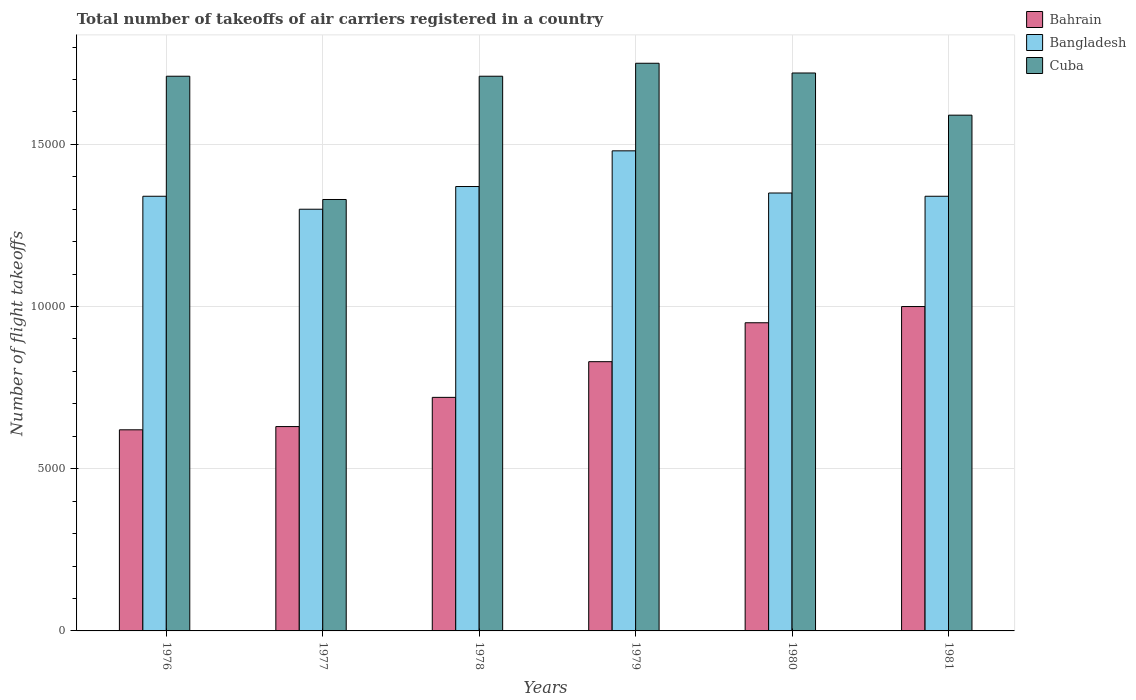How many different coloured bars are there?
Your answer should be compact. 3. Are the number of bars on each tick of the X-axis equal?
Provide a short and direct response. Yes. How many bars are there on the 5th tick from the right?
Provide a succinct answer. 3. In how many cases, is the number of bars for a given year not equal to the number of legend labels?
Keep it short and to the point. 0. What is the total number of flight takeoffs in Cuba in 1978?
Ensure brevity in your answer.  1.71e+04. Across all years, what is the minimum total number of flight takeoffs in Cuba?
Give a very brief answer. 1.33e+04. In which year was the total number of flight takeoffs in Cuba maximum?
Your answer should be very brief. 1979. In which year was the total number of flight takeoffs in Cuba minimum?
Provide a short and direct response. 1977. What is the total total number of flight takeoffs in Bahrain in the graph?
Make the answer very short. 4.75e+04. What is the difference between the total number of flight takeoffs in Bangladesh in 1979 and that in 1981?
Your answer should be compact. 1400. What is the difference between the total number of flight takeoffs in Cuba in 1976 and the total number of flight takeoffs in Bangladesh in 1978?
Make the answer very short. 3400. What is the average total number of flight takeoffs in Bangladesh per year?
Give a very brief answer. 1.36e+04. In the year 1979, what is the difference between the total number of flight takeoffs in Bahrain and total number of flight takeoffs in Cuba?
Ensure brevity in your answer.  -9200. In how many years, is the total number of flight takeoffs in Cuba greater than 8000?
Ensure brevity in your answer.  6. What is the ratio of the total number of flight takeoffs in Cuba in 1977 to that in 1979?
Ensure brevity in your answer.  0.76. Is the total number of flight takeoffs in Bangladesh in 1979 less than that in 1981?
Ensure brevity in your answer.  No. Is the difference between the total number of flight takeoffs in Bahrain in 1977 and 1979 greater than the difference between the total number of flight takeoffs in Cuba in 1977 and 1979?
Offer a very short reply. Yes. What is the difference between the highest and the lowest total number of flight takeoffs in Bahrain?
Make the answer very short. 3800. In how many years, is the total number of flight takeoffs in Bangladesh greater than the average total number of flight takeoffs in Bangladesh taken over all years?
Your answer should be very brief. 2. What does the 1st bar from the left in 1978 represents?
Your answer should be very brief. Bahrain. What does the 1st bar from the right in 1978 represents?
Your response must be concise. Cuba. What is the difference between two consecutive major ticks on the Y-axis?
Ensure brevity in your answer.  5000. Are the values on the major ticks of Y-axis written in scientific E-notation?
Offer a very short reply. No. Does the graph contain any zero values?
Provide a short and direct response. No. How are the legend labels stacked?
Your answer should be compact. Vertical. What is the title of the graph?
Your answer should be compact. Total number of takeoffs of air carriers registered in a country. Does "Curacao" appear as one of the legend labels in the graph?
Provide a short and direct response. No. What is the label or title of the Y-axis?
Keep it short and to the point. Number of flight takeoffs. What is the Number of flight takeoffs of Bahrain in 1976?
Offer a very short reply. 6200. What is the Number of flight takeoffs of Bangladesh in 1976?
Provide a succinct answer. 1.34e+04. What is the Number of flight takeoffs in Cuba in 1976?
Ensure brevity in your answer.  1.71e+04. What is the Number of flight takeoffs of Bahrain in 1977?
Make the answer very short. 6300. What is the Number of flight takeoffs of Bangladesh in 1977?
Offer a very short reply. 1.30e+04. What is the Number of flight takeoffs in Cuba in 1977?
Ensure brevity in your answer.  1.33e+04. What is the Number of flight takeoffs of Bahrain in 1978?
Make the answer very short. 7200. What is the Number of flight takeoffs of Bangladesh in 1978?
Ensure brevity in your answer.  1.37e+04. What is the Number of flight takeoffs in Cuba in 1978?
Your response must be concise. 1.71e+04. What is the Number of flight takeoffs in Bahrain in 1979?
Your answer should be very brief. 8300. What is the Number of flight takeoffs in Bangladesh in 1979?
Offer a very short reply. 1.48e+04. What is the Number of flight takeoffs of Cuba in 1979?
Offer a very short reply. 1.75e+04. What is the Number of flight takeoffs of Bahrain in 1980?
Provide a succinct answer. 9500. What is the Number of flight takeoffs in Bangladesh in 1980?
Give a very brief answer. 1.35e+04. What is the Number of flight takeoffs of Cuba in 1980?
Give a very brief answer. 1.72e+04. What is the Number of flight takeoffs in Bangladesh in 1981?
Your answer should be compact. 1.34e+04. What is the Number of flight takeoffs of Cuba in 1981?
Provide a succinct answer. 1.59e+04. Across all years, what is the maximum Number of flight takeoffs of Bahrain?
Ensure brevity in your answer.  10000. Across all years, what is the maximum Number of flight takeoffs in Bangladesh?
Keep it short and to the point. 1.48e+04. Across all years, what is the maximum Number of flight takeoffs of Cuba?
Offer a terse response. 1.75e+04. Across all years, what is the minimum Number of flight takeoffs of Bahrain?
Provide a succinct answer. 6200. Across all years, what is the minimum Number of flight takeoffs in Bangladesh?
Offer a terse response. 1.30e+04. Across all years, what is the minimum Number of flight takeoffs of Cuba?
Give a very brief answer. 1.33e+04. What is the total Number of flight takeoffs in Bahrain in the graph?
Ensure brevity in your answer.  4.75e+04. What is the total Number of flight takeoffs in Bangladesh in the graph?
Make the answer very short. 8.18e+04. What is the total Number of flight takeoffs of Cuba in the graph?
Your answer should be compact. 9.81e+04. What is the difference between the Number of flight takeoffs of Bahrain in 1976 and that in 1977?
Your answer should be very brief. -100. What is the difference between the Number of flight takeoffs of Bangladesh in 1976 and that in 1977?
Give a very brief answer. 400. What is the difference between the Number of flight takeoffs of Cuba in 1976 and that in 1977?
Give a very brief answer. 3800. What is the difference between the Number of flight takeoffs of Bahrain in 1976 and that in 1978?
Offer a very short reply. -1000. What is the difference between the Number of flight takeoffs of Bangladesh in 1976 and that in 1978?
Give a very brief answer. -300. What is the difference between the Number of flight takeoffs in Bahrain in 1976 and that in 1979?
Offer a terse response. -2100. What is the difference between the Number of flight takeoffs in Bangladesh in 1976 and that in 1979?
Offer a very short reply. -1400. What is the difference between the Number of flight takeoffs of Cuba in 1976 and that in 1979?
Your answer should be very brief. -400. What is the difference between the Number of flight takeoffs of Bahrain in 1976 and that in 1980?
Offer a terse response. -3300. What is the difference between the Number of flight takeoffs in Bangladesh in 1976 and that in 1980?
Provide a short and direct response. -100. What is the difference between the Number of flight takeoffs in Cuba in 1976 and that in 1980?
Your answer should be compact. -100. What is the difference between the Number of flight takeoffs of Bahrain in 1976 and that in 1981?
Your answer should be compact. -3800. What is the difference between the Number of flight takeoffs in Cuba in 1976 and that in 1981?
Offer a very short reply. 1200. What is the difference between the Number of flight takeoffs of Bahrain in 1977 and that in 1978?
Keep it short and to the point. -900. What is the difference between the Number of flight takeoffs in Bangladesh in 1977 and that in 1978?
Provide a short and direct response. -700. What is the difference between the Number of flight takeoffs of Cuba in 1977 and that in 1978?
Offer a very short reply. -3800. What is the difference between the Number of flight takeoffs in Bahrain in 1977 and that in 1979?
Offer a terse response. -2000. What is the difference between the Number of flight takeoffs in Bangladesh in 1977 and that in 1979?
Provide a short and direct response. -1800. What is the difference between the Number of flight takeoffs in Cuba in 1977 and that in 1979?
Your answer should be compact. -4200. What is the difference between the Number of flight takeoffs in Bahrain in 1977 and that in 1980?
Give a very brief answer. -3200. What is the difference between the Number of flight takeoffs in Bangladesh in 1977 and that in 1980?
Provide a succinct answer. -500. What is the difference between the Number of flight takeoffs of Cuba in 1977 and that in 1980?
Offer a very short reply. -3900. What is the difference between the Number of flight takeoffs in Bahrain in 1977 and that in 1981?
Offer a very short reply. -3700. What is the difference between the Number of flight takeoffs in Bangladesh in 1977 and that in 1981?
Your response must be concise. -400. What is the difference between the Number of flight takeoffs of Cuba in 1977 and that in 1981?
Ensure brevity in your answer.  -2600. What is the difference between the Number of flight takeoffs of Bahrain in 1978 and that in 1979?
Give a very brief answer. -1100. What is the difference between the Number of flight takeoffs of Bangladesh in 1978 and that in 1979?
Your response must be concise. -1100. What is the difference between the Number of flight takeoffs in Cuba in 1978 and that in 1979?
Offer a terse response. -400. What is the difference between the Number of flight takeoffs of Bahrain in 1978 and that in 1980?
Keep it short and to the point. -2300. What is the difference between the Number of flight takeoffs in Bangladesh in 1978 and that in 1980?
Make the answer very short. 200. What is the difference between the Number of flight takeoffs of Cuba in 1978 and that in 1980?
Ensure brevity in your answer.  -100. What is the difference between the Number of flight takeoffs in Bahrain in 1978 and that in 1981?
Offer a terse response. -2800. What is the difference between the Number of flight takeoffs of Bangladesh in 1978 and that in 1981?
Keep it short and to the point. 300. What is the difference between the Number of flight takeoffs of Cuba in 1978 and that in 1981?
Your answer should be compact. 1200. What is the difference between the Number of flight takeoffs of Bahrain in 1979 and that in 1980?
Keep it short and to the point. -1200. What is the difference between the Number of flight takeoffs of Bangladesh in 1979 and that in 1980?
Provide a succinct answer. 1300. What is the difference between the Number of flight takeoffs of Cuba in 1979 and that in 1980?
Keep it short and to the point. 300. What is the difference between the Number of flight takeoffs of Bahrain in 1979 and that in 1981?
Your response must be concise. -1700. What is the difference between the Number of flight takeoffs in Bangladesh in 1979 and that in 1981?
Offer a very short reply. 1400. What is the difference between the Number of flight takeoffs of Cuba in 1979 and that in 1981?
Your answer should be very brief. 1600. What is the difference between the Number of flight takeoffs of Bahrain in 1980 and that in 1981?
Keep it short and to the point. -500. What is the difference between the Number of flight takeoffs of Cuba in 1980 and that in 1981?
Your response must be concise. 1300. What is the difference between the Number of flight takeoffs in Bahrain in 1976 and the Number of flight takeoffs in Bangladesh in 1977?
Keep it short and to the point. -6800. What is the difference between the Number of flight takeoffs in Bahrain in 1976 and the Number of flight takeoffs in Cuba in 1977?
Ensure brevity in your answer.  -7100. What is the difference between the Number of flight takeoffs in Bahrain in 1976 and the Number of flight takeoffs in Bangladesh in 1978?
Keep it short and to the point. -7500. What is the difference between the Number of flight takeoffs in Bahrain in 1976 and the Number of flight takeoffs in Cuba in 1978?
Your response must be concise. -1.09e+04. What is the difference between the Number of flight takeoffs of Bangladesh in 1976 and the Number of flight takeoffs of Cuba in 1978?
Offer a very short reply. -3700. What is the difference between the Number of flight takeoffs of Bahrain in 1976 and the Number of flight takeoffs of Bangladesh in 1979?
Provide a succinct answer. -8600. What is the difference between the Number of flight takeoffs in Bahrain in 1976 and the Number of flight takeoffs in Cuba in 1979?
Ensure brevity in your answer.  -1.13e+04. What is the difference between the Number of flight takeoffs in Bangladesh in 1976 and the Number of flight takeoffs in Cuba in 1979?
Ensure brevity in your answer.  -4100. What is the difference between the Number of flight takeoffs of Bahrain in 1976 and the Number of flight takeoffs of Bangladesh in 1980?
Provide a short and direct response. -7300. What is the difference between the Number of flight takeoffs in Bahrain in 1976 and the Number of flight takeoffs in Cuba in 1980?
Offer a terse response. -1.10e+04. What is the difference between the Number of flight takeoffs in Bangladesh in 1976 and the Number of flight takeoffs in Cuba in 1980?
Your response must be concise. -3800. What is the difference between the Number of flight takeoffs in Bahrain in 1976 and the Number of flight takeoffs in Bangladesh in 1981?
Ensure brevity in your answer.  -7200. What is the difference between the Number of flight takeoffs in Bahrain in 1976 and the Number of flight takeoffs in Cuba in 1981?
Give a very brief answer. -9700. What is the difference between the Number of flight takeoffs of Bangladesh in 1976 and the Number of flight takeoffs of Cuba in 1981?
Provide a short and direct response. -2500. What is the difference between the Number of flight takeoffs in Bahrain in 1977 and the Number of flight takeoffs in Bangladesh in 1978?
Give a very brief answer. -7400. What is the difference between the Number of flight takeoffs in Bahrain in 1977 and the Number of flight takeoffs in Cuba in 1978?
Your answer should be very brief. -1.08e+04. What is the difference between the Number of flight takeoffs in Bangladesh in 1977 and the Number of flight takeoffs in Cuba in 1978?
Your answer should be compact. -4100. What is the difference between the Number of flight takeoffs of Bahrain in 1977 and the Number of flight takeoffs of Bangladesh in 1979?
Your answer should be very brief. -8500. What is the difference between the Number of flight takeoffs in Bahrain in 1977 and the Number of flight takeoffs in Cuba in 1979?
Ensure brevity in your answer.  -1.12e+04. What is the difference between the Number of flight takeoffs of Bangladesh in 1977 and the Number of flight takeoffs of Cuba in 1979?
Offer a terse response. -4500. What is the difference between the Number of flight takeoffs in Bahrain in 1977 and the Number of flight takeoffs in Bangladesh in 1980?
Your answer should be compact. -7200. What is the difference between the Number of flight takeoffs in Bahrain in 1977 and the Number of flight takeoffs in Cuba in 1980?
Provide a short and direct response. -1.09e+04. What is the difference between the Number of flight takeoffs of Bangladesh in 1977 and the Number of flight takeoffs of Cuba in 1980?
Make the answer very short. -4200. What is the difference between the Number of flight takeoffs of Bahrain in 1977 and the Number of flight takeoffs of Bangladesh in 1981?
Keep it short and to the point. -7100. What is the difference between the Number of flight takeoffs of Bahrain in 1977 and the Number of flight takeoffs of Cuba in 1981?
Your response must be concise. -9600. What is the difference between the Number of flight takeoffs of Bangladesh in 1977 and the Number of flight takeoffs of Cuba in 1981?
Provide a short and direct response. -2900. What is the difference between the Number of flight takeoffs in Bahrain in 1978 and the Number of flight takeoffs in Bangladesh in 1979?
Your answer should be very brief. -7600. What is the difference between the Number of flight takeoffs in Bahrain in 1978 and the Number of flight takeoffs in Cuba in 1979?
Give a very brief answer. -1.03e+04. What is the difference between the Number of flight takeoffs of Bangladesh in 1978 and the Number of flight takeoffs of Cuba in 1979?
Your answer should be compact. -3800. What is the difference between the Number of flight takeoffs in Bahrain in 1978 and the Number of flight takeoffs in Bangladesh in 1980?
Provide a succinct answer. -6300. What is the difference between the Number of flight takeoffs in Bangladesh in 1978 and the Number of flight takeoffs in Cuba in 1980?
Your answer should be very brief. -3500. What is the difference between the Number of flight takeoffs in Bahrain in 1978 and the Number of flight takeoffs in Bangladesh in 1981?
Keep it short and to the point. -6200. What is the difference between the Number of flight takeoffs of Bahrain in 1978 and the Number of flight takeoffs of Cuba in 1981?
Your response must be concise. -8700. What is the difference between the Number of flight takeoffs in Bangladesh in 1978 and the Number of flight takeoffs in Cuba in 1981?
Your response must be concise. -2200. What is the difference between the Number of flight takeoffs of Bahrain in 1979 and the Number of flight takeoffs of Bangladesh in 1980?
Your answer should be compact. -5200. What is the difference between the Number of flight takeoffs in Bahrain in 1979 and the Number of flight takeoffs in Cuba in 1980?
Offer a terse response. -8900. What is the difference between the Number of flight takeoffs of Bangladesh in 1979 and the Number of flight takeoffs of Cuba in 1980?
Offer a very short reply. -2400. What is the difference between the Number of flight takeoffs in Bahrain in 1979 and the Number of flight takeoffs in Bangladesh in 1981?
Ensure brevity in your answer.  -5100. What is the difference between the Number of flight takeoffs in Bahrain in 1979 and the Number of flight takeoffs in Cuba in 1981?
Provide a short and direct response. -7600. What is the difference between the Number of flight takeoffs of Bangladesh in 1979 and the Number of flight takeoffs of Cuba in 1981?
Your answer should be compact. -1100. What is the difference between the Number of flight takeoffs in Bahrain in 1980 and the Number of flight takeoffs in Bangladesh in 1981?
Offer a very short reply. -3900. What is the difference between the Number of flight takeoffs of Bahrain in 1980 and the Number of flight takeoffs of Cuba in 1981?
Offer a terse response. -6400. What is the difference between the Number of flight takeoffs in Bangladesh in 1980 and the Number of flight takeoffs in Cuba in 1981?
Make the answer very short. -2400. What is the average Number of flight takeoffs of Bahrain per year?
Your response must be concise. 7916.67. What is the average Number of flight takeoffs in Bangladesh per year?
Keep it short and to the point. 1.36e+04. What is the average Number of flight takeoffs in Cuba per year?
Give a very brief answer. 1.64e+04. In the year 1976, what is the difference between the Number of flight takeoffs of Bahrain and Number of flight takeoffs of Bangladesh?
Offer a terse response. -7200. In the year 1976, what is the difference between the Number of flight takeoffs in Bahrain and Number of flight takeoffs in Cuba?
Offer a terse response. -1.09e+04. In the year 1976, what is the difference between the Number of flight takeoffs in Bangladesh and Number of flight takeoffs in Cuba?
Make the answer very short. -3700. In the year 1977, what is the difference between the Number of flight takeoffs in Bahrain and Number of flight takeoffs in Bangladesh?
Give a very brief answer. -6700. In the year 1977, what is the difference between the Number of flight takeoffs of Bahrain and Number of flight takeoffs of Cuba?
Your answer should be very brief. -7000. In the year 1977, what is the difference between the Number of flight takeoffs in Bangladesh and Number of flight takeoffs in Cuba?
Offer a very short reply. -300. In the year 1978, what is the difference between the Number of flight takeoffs of Bahrain and Number of flight takeoffs of Bangladesh?
Provide a succinct answer. -6500. In the year 1978, what is the difference between the Number of flight takeoffs of Bahrain and Number of flight takeoffs of Cuba?
Provide a succinct answer. -9900. In the year 1978, what is the difference between the Number of flight takeoffs in Bangladesh and Number of flight takeoffs in Cuba?
Your answer should be compact. -3400. In the year 1979, what is the difference between the Number of flight takeoffs in Bahrain and Number of flight takeoffs in Bangladesh?
Make the answer very short. -6500. In the year 1979, what is the difference between the Number of flight takeoffs in Bahrain and Number of flight takeoffs in Cuba?
Ensure brevity in your answer.  -9200. In the year 1979, what is the difference between the Number of flight takeoffs in Bangladesh and Number of flight takeoffs in Cuba?
Offer a very short reply. -2700. In the year 1980, what is the difference between the Number of flight takeoffs in Bahrain and Number of flight takeoffs in Bangladesh?
Make the answer very short. -4000. In the year 1980, what is the difference between the Number of flight takeoffs of Bahrain and Number of flight takeoffs of Cuba?
Your response must be concise. -7700. In the year 1980, what is the difference between the Number of flight takeoffs of Bangladesh and Number of flight takeoffs of Cuba?
Offer a terse response. -3700. In the year 1981, what is the difference between the Number of flight takeoffs in Bahrain and Number of flight takeoffs in Bangladesh?
Your answer should be very brief. -3400. In the year 1981, what is the difference between the Number of flight takeoffs in Bahrain and Number of flight takeoffs in Cuba?
Ensure brevity in your answer.  -5900. In the year 1981, what is the difference between the Number of flight takeoffs in Bangladesh and Number of flight takeoffs in Cuba?
Your answer should be compact. -2500. What is the ratio of the Number of flight takeoffs in Bahrain in 1976 to that in 1977?
Provide a short and direct response. 0.98. What is the ratio of the Number of flight takeoffs in Bangladesh in 1976 to that in 1977?
Provide a short and direct response. 1.03. What is the ratio of the Number of flight takeoffs of Cuba in 1976 to that in 1977?
Make the answer very short. 1.29. What is the ratio of the Number of flight takeoffs of Bahrain in 1976 to that in 1978?
Offer a very short reply. 0.86. What is the ratio of the Number of flight takeoffs in Bangladesh in 1976 to that in 1978?
Provide a short and direct response. 0.98. What is the ratio of the Number of flight takeoffs in Cuba in 1976 to that in 1978?
Keep it short and to the point. 1. What is the ratio of the Number of flight takeoffs of Bahrain in 1976 to that in 1979?
Provide a succinct answer. 0.75. What is the ratio of the Number of flight takeoffs of Bangladesh in 1976 to that in 1979?
Offer a very short reply. 0.91. What is the ratio of the Number of flight takeoffs in Cuba in 1976 to that in 1979?
Your answer should be very brief. 0.98. What is the ratio of the Number of flight takeoffs in Bahrain in 1976 to that in 1980?
Ensure brevity in your answer.  0.65. What is the ratio of the Number of flight takeoffs in Bangladesh in 1976 to that in 1980?
Your answer should be compact. 0.99. What is the ratio of the Number of flight takeoffs of Cuba in 1976 to that in 1980?
Offer a terse response. 0.99. What is the ratio of the Number of flight takeoffs of Bahrain in 1976 to that in 1981?
Provide a short and direct response. 0.62. What is the ratio of the Number of flight takeoffs of Cuba in 1976 to that in 1981?
Your response must be concise. 1.08. What is the ratio of the Number of flight takeoffs of Bahrain in 1977 to that in 1978?
Offer a terse response. 0.88. What is the ratio of the Number of flight takeoffs in Bangladesh in 1977 to that in 1978?
Your answer should be very brief. 0.95. What is the ratio of the Number of flight takeoffs of Cuba in 1977 to that in 1978?
Ensure brevity in your answer.  0.78. What is the ratio of the Number of flight takeoffs in Bahrain in 1977 to that in 1979?
Give a very brief answer. 0.76. What is the ratio of the Number of flight takeoffs of Bangladesh in 1977 to that in 1979?
Give a very brief answer. 0.88. What is the ratio of the Number of flight takeoffs of Cuba in 1977 to that in 1979?
Provide a succinct answer. 0.76. What is the ratio of the Number of flight takeoffs of Bahrain in 1977 to that in 1980?
Your answer should be compact. 0.66. What is the ratio of the Number of flight takeoffs of Cuba in 1977 to that in 1980?
Offer a very short reply. 0.77. What is the ratio of the Number of flight takeoffs of Bahrain in 1977 to that in 1981?
Give a very brief answer. 0.63. What is the ratio of the Number of flight takeoffs in Bangladesh in 1977 to that in 1981?
Provide a short and direct response. 0.97. What is the ratio of the Number of flight takeoffs of Cuba in 1977 to that in 1981?
Provide a short and direct response. 0.84. What is the ratio of the Number of flight takeoffs in Bahrain in 1978 to that in 1979?
Keep it short and to the point. 0.87. What is the ratio of the Number of flight takeoffs in Bangladesh in 1978 to that in 1979?
Ensure brevity in your answer.  0.93. What is the ratio of the Number of flight takeoffs in Cuba in 1978 to that in 1979?
Provide a short and direct response. 0.98. What is the ratio of the Number of flight takeoffs of Bahrain in 1978 to that in 1980?
Provide a succinct answer. 0.76. What is the ratio of the Number of flight takeoffs of Bangladesh in 1978 to that in 1980?
Provide a short and direct response. 1.01. What is the ratio of the Number of flight takeoffs in Bahrain in 1978 to that in 1981?
Give a very brief answer. 0.72. What is the ratio of the Number of flight takeoffs of Bangladesh in 1978 to that in 1981?
Your answer should be compact. 1.02. What is the ratio of the Number of flight takeoffs in Cuba in 1978 to that in 1981?
Keep it short and to the point. 1.08. What is the ratio of the Number of flight takeoffs of Bahrain in 1979 to that in 1980?
Make the answer very short. 0.87. What is the ratio of the Number of flight takeoffs of Bangladesh in 1979 to that in 1980?
Offer a very short reply. 1.1. What is the ratio of the Number of flight takeoffs in Cuba in 1979 to that in 1980?
Your answer should be compact. 1.02. What is the ratio of the Number of flight takeoffs of Bahrain in 1979 to that in 1981?
Offer a very short reply. 0.83. What is the ratio of the Number of flight takeoffs in Bangladesh in 1979 to that in 1981?
Make the answer very short. 1.1. What is the ratio of the Number of flight takeoffs in Cuba in 1979 to that in 1981?
Keep it short and to the point. 1.1. What is the ratio of the Number of flight takeoffs of Bahrain in 1980 to that in 1981?
Give a very brief answer. 0.95. What is the ratio of the Number of flight takeoffs in Bangladesh in 1980 to that in 1981?
Provide a short and direct response. 1.01. What is the ratio of the Number of flight takeoffs in Cuba in 1980 to that in 1981?
Your answer should be very brief. 1.08. What is the difference between the highest and the second highest Number of flight takeoffs in Bangladesh?
Your answer should be compact. 1100. What is the difference between the highest and the second highest Number of flight takeoffs in Cuba?
Offer a very short reply. 300. What is the difference between the highest and the lowest Number of flight takeoffs of Bahrain?
Offer a very short reply. 3800. What is the difference between the highest and the lowest Number of flight takeoffs of Bangladesh?
Offer a terse response. 1800. What is the difference between the highest and the lowest Number of flight takeoffs of Cuba?
Give a very brief answer. 4200. 